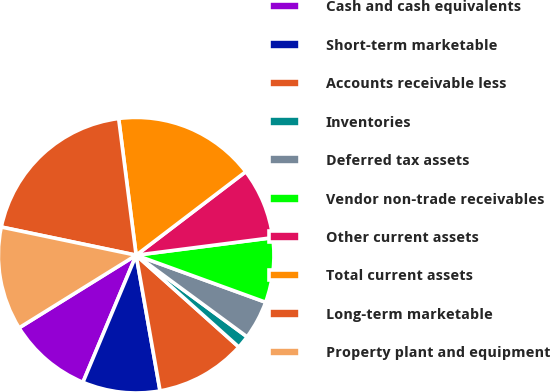Convert chart to OTSL. <chart><loc_0><loc_0><loc_500><loc_500><pie_chart><fcel>Cash and cash equivalents<fcel>Short-term marketable<fcel>Accounts receivable less<fcel>Inventories<fcel>Deferred tax assets<fcel>Vendor non-trade receivables<fcel>Other current assets<fcel>Total current assets<fcel>Long-term marketable<fcel>Property plant and equipment<nl><fcel>9.85%<fcel>9.09%<fcel>10.61%<fcel>1.52%<fcel>4.55%<fcel>7.58%<fcel>8.33%<fcel>16.67%<fcel>19.7%<fcel>12.12%<nl></chart> 